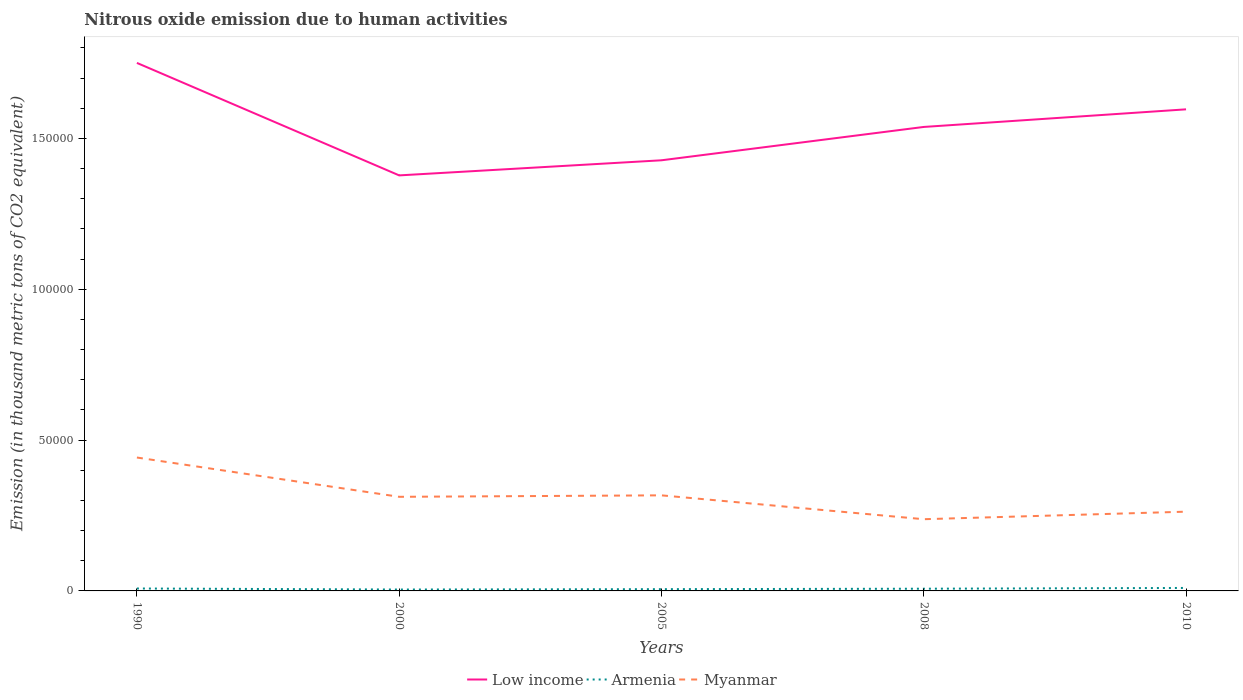How many different coloured lines are there?
Offer a very short reply. 3. Does the line corresponding to Armenia intersect with the line corresponding to Myanmar?
Offer a very short reply. No. Across all years, what is the maximum amount of nitrous oxide emitted in Myanmar?
Ensure brevity in your answer.  2.38e+04. In which year was the amount of nitrous oxide emitted in Myanmar maximum?
Keep it short and to the point. 2008. What is the total amount of nitrous oxide emitted in Myanmar in the graph?
Provide a short and direct response. -2497.4. What is the difference between the highest and the second highest amount of nitrous oxide emitted in Myanmar?
Give a very brief answer. 2.04e+04. How many years are there in the graph?
Keep it short and to the point. 5. Does the graph contain grids?
Give a very brief answer. No. How many legend labels are there?
Your response must be concise. 3. How are the legend labels stacked?
Provide a short and direct response. Horizontal. What is the title of the graph?
Keep it short and to the point. Nitrous oxide emission due to human activities. What is the label or title of the X-axis?
Ensure brevity in your answer.  Years. What is the label or title of the Y-axis?
Make the answer very short. Emission (in thousand metric tons of CO2 equivalent). What is the Emission (in thousand metric tons of CO2 equivalent) in Low income in 1990?
Offer a very short reply. 1.75e+05. What is the Emission (in thousand metric tons of CO2 equivalent) in Armenia in 1990?
Ensure brevity in your answer.  805. What is the Emission (in thousand metric tons of CO2 equivalent) of Myanmar in 1990?
Make the answer very short. 4.42e+04. What is the Emission (in thousand metric tons of CO2 equivalent) of Low income in 2000?
Your answer should be compact. 1.38e+05. What is the Emission (in thousand metric tons of CO2 equivalent) of Armenia in 2000?
Your answer should be compact. 461.6. What is the Emission (in thousand metric tons of CO2 equivalent) in Myanmar in 2000?
Provide a short and direct response. 3.12e+04. What is the Emission (in thousand metric tons of CO2 equivalent) of Low income in 2005?
Your answer should be compact. 1.43e+05. What is the Emission (in thousand metric tons of CO2 equivalent) of Armenia in 2005?
Give a very brief answer. 583.5. What is the Emission (in thousand metric tons of CO2 equivalent) of Myanmar in 2005?
Ensure brevity in your answer.  3.17e+04. What is the Emission (in thousand metric tons of CO2 equivalent) in Low income in 2008?
Keep it short and to the point. 1.54e+05. What is the Emission (in thousand metric tons of CO2 equivalent) in Armenia in 2008?
Ensure brevity in your answer.  731.4. What is the Emission (in thousand metric tons of CO2 equivalent) of Myanmar in 2008?
Give a very brief answer. 2.38e+04. What is the Emission (in thousand metric tons of CO2 equivalent) in Low income in 2010?
Provide a short and direct response. 1.60e+05. What is the Emission (in thousand metric tons of CO2 equivalent) of Armenia in 2010?
Offer a very short reply. 985.9. What is the Emission (in thousand metric tons of CO2 equivalent) in Myanmar in 2010?
Provide a succinct answer. 2.63e+04. Across all years, what is the maximum Emission (in thousand metric tons of CO2 equivalent) of Low income?
Make the answer very short. 1.75e+05. Across all years, what is the maximum Emission (in thousand metric tons of CO2 equivalent) of Armenia?
Your answer should be compact. 985.9. Across all years, what is the maximum Emission (in thousand metric tons of CO2 equivalent) of Myanmar?
Your response must be concise. 4.42e+04. Across all years, what is the minimum Emission (in thousand metric tons of CO2 equivalent) in Low income?
Your response must be concise. 1.38e+05. Across all years, what is the minimum Emission (in thousand metric tons of CO2 equivalent) in Armenia?
Keep it short and to the point. 461.6. Across all years, what is the minimum Emission (in thousand metric tons of CO2 equivalent) in Myanmar?
Your answer should be compact. 2.38e+04. What is the total Emission (in thousand metric tons of CO2 equivalent) in Low income in the graph?
Your answer should be very brief. 7.69e+05. What is the total Emission (in thousand metric tons of CO2 equivalent) in Armenia in the graph?
Your response must be concise. 3567.4. What is the total Emission (in thousand metric tons of CO2 equivalent) of Myanmar in the graph?
Ensure brevity in your answer.  1.57e+05. What is the difference between the Emission (in thousand metric tons of CO2 equivalent) in Low income in 1990 and that in 2000?
Your answer should be very brief. 3.73e+04. What is the difference between the Emission (in thousand metric tons of CO2 equivalent) of Armenia in 1990 and that in 2000?
Give a very brief answer. 343.4. What is the difference between the Emission (in thousand metric tons of CO2 equivalent) of Myanmar in 1990 and that in 2000?
Give a very brief answer. 1.30e+04. What is the difference between the Emission (in thousand metric tons of CO2 equivalent) in Low income in 1990 and that in 2005?
Your answer should be very brief. 3.23e+04. What is the difference between the Emission (in thousand metric tons of CO2 equivalent) of Armenia in 1990 and that in 2005?
Provide a short and direct response. 221.5. What is the difference between the Emission (in thousand metric tons of CO2 equivalent) of Myanmar in 1990 and that in 2005?
Offer a very short reply. 1.25e+04. What is the difference between the Emission (in thousand metric tons of CO2 equivalent) of Low income in 1990 and that in 2008?
Ensure brevity in your answer.  2.12e+04. What is the difference between the Emission (in thousand metric tons of CO2 equivalent) in Armenia in 1990 and that in 2008?
Your response must be concise. 73.6. What is the difference between the Emission (in thousand metric tons of CO2 equivalent) in Myanmar in 1990 and that in 2008?
Your answer should be compact. 2.04e+04. What is the difference between the Emission (in thousand metric tons of CO2 equivalent) in Low income in 1990 and that in 2010?
Provide a short and direct response. 1.54e+04. What is the difference between the Emission (in thousand metric tons of CO2 equivalent) in Armenia in 1990 and that in 2010?
Offer a very short reply. -180.9. What is the difference between the Emission (in thousand metric tons of CO2 equivalent) of Myanmar in 1990 and that in 2010?
Your answer should be very brief. 1.80e+04. What is the difference between the Emission (in thousand metric tons of CO2 equivalent) of Low income in 2000 and that in 2005?
Offer a terse response. -5007.3. What is the difference between the Emission (in thousand metric tons of CO2 equivalent) of Armenia in 2000 and that in 2005?
Ensure brevity in your answer.  -121.9. What is the difference between the Emission (in thousand metric tons of CO2 equivalent) of Myanmar in 2000 and that in 2005?
Give a very brief answer. -485.9. What is the difference between the Emission (in thousand metric tons of CO2 equivalent) of Low income in 2000 and that in 2008?
Make the answer very short. -1.61e+04. What is the difference between the Emission (in thousand metric tons of CO2 equivalent) in Armenia in 2000 and that in 2008?
Offer a very short reply. -269.8. What is the difference between the Emission (in thousand metric tons of CO2 equivalent) in Myanmar in 2000 and that in 2008?
Provide a succinct answer. 7425.1. What is the difference between the Emission (in thousand metric tons of CO2 equivalent) in Low income in 2000 and that in 2010?
Your answer should be compact. -2.19e+04. What is the difference between the Emission (in thousand metric tons of CO2 equivalent) of Armenia in 2000 and that in 2010?
Make the answer very short. -524.3. What is the difference between the Emission (in thousand metric tons of CO2 equivalent) of Myanmar in 2000 and that in 2010?
Give a very brief answer. 4927.7. What is the difference between the Emission (in thousand metric tons of CO2 equivalent) of Low income in 2005 and that in 2008?
Ensure brevity in your answer.  -1.11e+04. What is the difference between the Emission (in thousand metric tons of CO2 equivalent) of Armenia in 2005 and that in 2008?
Give a very brief answer. -147.9. What is the difference between the Emission (in thousand metric tons of CO2 equivalent) of Myanmar in 2005 and that in 2008?
Provide a succinct answer. 7911. What is the difference between the Emission (in thousand metric tons of CO2 equivalent) in Low income in 2005 and that in 2010?
Your response must be concise. -1.69e+04. What is the difference between the Emission (in thousand metric tons of CO2 equivalent) in Armenia in 2005 and that in 2010?
Give a very brief answer. -402.4. What is the difference between the Emission (in thousand metric tons of CO2 equivalent) of Myanmar in 2005 and that in 2010?
Offer a terse response. 5413.6. What is the difference between the Emission (in thousand metric tons of CO2 equivalent) in Low income in 2008 and that in 2010?
Make the answer very short. -5836.5. What is the difference between the Emission (in thousand metric tons of CO2 equivalent) of Armenia in 2008 and that in 2010?
Make the answer very short. -254.5. What is the difference between the Emission (in thousand metric tons of CO2 equivalent) in Myanmar in 2008 and that in 2010?
Your answer should be compact. -2497.4. What is the difference between the Emission (in thousand metric tons of CO2 equivalent) in Low income in 1990 and the Emission (in thousand metric tons of CO2 equivalent) in Armenia in 2000?
Keep it short and to the point. 1.75e+05. What is the difference between the Emission (in thousand metric tons of CO2 equivalent) in Low income in 1990 and the Emission (in thousand metric tons of CO2 equivalent) in Myanmar in 2000?
Keep it short and to the point. 1.44e+05. What is the difference between the Emission (in thousand metric tons of CO2 equivalent) in Armenia in 1990 and the Emission (in thousand metric tons of CO2 equivalent) in Myanmar in 2000?
Provide a short and direct response. -3.04e+04. What is the difference between the Emission (in thousand metric tons of CO2 equivalent) of Low income in 1990 and the Emission (in thousand metric tons of CO2 equivalent) of Armenia in 2005?
Keep it short and to the point. 1.74e+05. What is the difference between the Emission (in thousand metric tons of CO2 equivalent) in Low income in 1990 and the Emission (in thousand metric tons of CO2 equivalent) in Myanmar in 2005?
Provide a short and direct response. 1.43e+05. What is the difference between the Emission (in thousand metric tons of CO2 equivalent) in Armenia in 1990 and the Emission (in thousand metric tons of CO2 equivalent) in Myanmar in 2005?
Keep it short and to the point. -3.09e+04. What is the difference between the Emission (in thousand metric tons of CO2 equivalent) in Low income in 1990 and the Emission (in thousand metric tons of CO2 equivalent) in Armenia in 2008?
Your answer should be very brief. 1.74e+05. What is the difference between the Emission (in thousand metric tons of CO2 equivalent) of Low income in 1990 and the Emission (in thousand metric tons of CO2 equivalent) of Myanmar in 2008?
Provide a short and direct response. 1.51e+05. What is the difference between the Emission (in thousand metric tons of CO2 equivalent) in Armenia in 1990 and the Emission (in thousand metric tons of CO2 equivalent) in Myanmar in 2008?
Make the answer very short. -2.30e+04. What is the difference between the Emission (in thousand metric tons of CO2 equivalent) in Low income in 1990 and the Emission (in thousand metric tons of CO2 equivalent) in Armenia in 2010?
Make the answer very short. 1.74e+05. What is the difference between the Emission (in thousand metric tons of CO2 equivalent) of Low income in 1990 and the Emission (in thousand metric tons of CO2 equivalent) of Myanmar in 2010?
Offer a terse response. 1.49e+05. What is the difference between the Emission (in thousand metric tons of CO2 equivalent) of Armenia in 1990 and the Emission (in thousand metric tons of CO2 equivalent) of Myanmar in 2010?
Provide a succinct answer. -2.55e+04. What is the difference between the Emission (in thousand metric tons of CO2 equivalent) of Low income in 2000 and the Emission (in thousand metric tons of CO2 equivalent) of Armenia in 2005?
Make the answer very short. 1.37e+05. What is the difference between the Emission (in thousand metric tons of CO2 equivalent) of Low income in 2000 and the Emission (in thousand metric tons of CO2 equivalent) of Myanmar in 2005?
Give a very brief answer. 1.06e+05. What is the difference between the Emission (in thousand metric tons of CO2 equivalent) of Armenia in 2000 and the Emission (in thousand metric tons of CO2 equivalent) of Myanmar in 2005?
Provide a succinct answer. -3.12e+04. What is the difference between the Emission (in thousand metric tons of CO2 equivalent) in Low income in 2000 and the Emission (in thousand metric tons of CO2 equivalent) in Armenia in 2008?
Offer a very short reply. 1.37e+05. What is the difference between the Emission (in thousand metric tons of CO2 equivalent) of Low income in 2000 and the Emission (in thousand metric tons of CO2 equivalent) of Myanmar in 2008?
Make the answer very short. 1.14e+05. What is the difference between the Emission (in thousand metric tons of CO2 equivalent) in Armenia in 2000 and the Emission (in thousand metric tons of CO2 equivalent) in Myanmar in 2008?
Your response must be concise. -2.33e+04. What is the difference between the Emission (in thousand metric tons of CO2 equivalent) of Low income in 2000 and the Emission (in thousand metric tons of CO2 equivalent) of Armenia in 2010?
Make the answer very short. 1.37e+05. What is the difference between the Emission (in thousand metric tons of CO2 equivalent) of Low income in 2000 and the Emission (in thousand metric tons of CO2 equivalent) of Myanmar in 2010?
Give a very brief answer. 1.11e+05. What is the difference between the Emission (in thousand metric tons of CO2 equivalent) of Armenia in 2000 and the Emission (in thousand metric tons of CO2 equivalent) of Myanmar in 2010?
Ensure brevity in your answer.  -2.58e+04. What is the difference between the Emission (in thousand metric tons of CO2 equivalent) in Low income in 2005 and the Emission (in thousand metric tons of CO2 equivalent) in Armenia in 2008?
Make the answer very short. 1.42e+05. What is the difference between the Emission (in thousand metric tons of CO2 equivalent) in Low income in 2005 and the Emission (in thousand metric tons of CO2 equivalent) in Myanmar in 2008?
Provide a short and direct response. 1.19e+05. What is the difference between the Emission (in thousand metric tons of CO2 equivalent) in Armenia in 2005 and the Emission (in thousand metric tons of CO2 equivalent) in Myanmar in 2008?
Your answer should be very brief. -2.32e+04. What is the difference between the Emission (in thousand metric tons of CO2 equivalent) of Low income in 2005 and the Emission (in thousand metric tons of CO2 equivalent) of Armenia in 2010?
Keep it short and to the point. 1.42e+05. What is the difference between the Emission (in thousand metric tons of CO2 equivalent) of Low income in 2005 and the Emission (in thousand metric tons of CO2 equivalent) of Myanmar in 2010?
Offer a very short reply. 1.16e+05. What is the difference between the Emission (in thousand metric tons of CO2 equivalent) in Armenia in 2005 and the Emission (in thousand metric tons of CO2 equivalent) in Myanmar in 2010?
Make the answer very short. -2.57e+04. What is the difference between the Emission (in thousand metric tons of CO2 equivalent) in Low income in 2008 and the Emission (in thousand metric tons of CO2 equivalent) in Armenia in 2010?
Provide a short and direct response. 1.53e+05. What is the difference between the Emission (in thousand metric tons of CO2 equivalent) in Low income in 2008 and the Emission (in thousand metric tons of CO2 equivalent) in Myanmar in 2010?
Offer a terse response. 1.28e+05. What is the difference between the Emission (in thousand metric tons of CO2 equivalent) in Armenia in 2008 and the Emission (in thousand metric tons of CO2 equivalent) in Myanmar in 2010?
Offer a very short reply. -2.55e+04. What is the average Emission (in thousand metric tons of CO2 equivalent) in Low income per year?
Provide a succinct answer. 1.54e+05. What is the average Emission (in thousand metric tons of CO2 equivalent) of Armenia per year?
Keep it short and to the point. 713.48. What is the average Emission (in thousand metric tons of CO2 equivalent) of Myanmar per year?
Your answer should be very brief. 3.14e+04. In the year 1990, what is the difference between the Emission (in thousand metric tons of CO2 equivalent) in Low income and Emission (in thousand metric tons of CO2 equivalent) in Armenia?
Your response must be concise. 1.74e+05. In the year 1990, what is the difference between the Emission (in thousand metric tons of CO2 equivalent) in Low income and Emission (in thousand metric tons of CO2 equivalent) in Myanmar?
Ensure brevity in your answer.  1.31e+05. In the year 1990, what is the difference between the Emission (in thousand metric tons of CO2 equivalent) of Armenia and Emission (in thousand metric tons of CO2 equivalent) of Myanmar?
Offer a terse response. -4.34e+04. In the year 2000, what is the difference between the Emission (in thousand metric tons of CO2 equivalent) of Low income and Emission (in thousand metric tons of CO2 equivalent) of Armenia?
Offer a terse response. 1.37e+05. In the year 2000, what is the difference between the Emission (in thousand metric tons of CO2 equivalent) of Low income and Emission (in thousand metric tons of CO2 equivalent) of Myanmar?
Keep it short and to the point. 1.07e+05. In the year 2000, what is the difference between the Emission (in thousand metric tons of CO2 equivalent) in Armenia and Emission (in thousand metric tons of CO2 equivalent) in Myanmar?
Provide a short and direct response. -3.07e+04. In the year 2005, what is the difference between the Emission (in thousand metric tons of CO2 equivalent) of Low income and Emission (in thousand metric tons of CO2 equivalent) of Armenia?
Your response must be concise. 1.42e+05. In the year 2005, what is the difference between the Emission (in thousand metric tons of CO2 equivalent) of Low income and Emission (in thousand metric tons of CO2 equivalent) of Myanmar?
Provide a succinct answer. 1.11e+05. In the year 2005, what is the difference between the Emission (in thousand metric tons of CO2 equivalent) in Armenia and Emission (in thousand metric tons of CO2 equivalent) in Myanmar?
Your answer should be very brief. -3.11e+04. In the year 2008, what is the difference between the Emission (in thousand metric tons of CO2 equivalent) of Low income and Emission (in thousand metric tons of CO2 equivalent) of Armenia?
Ensure brevity in your answer.  1.53e+05. In the year 2008, what is the difference between the Emission (in thousand metric tons of CO2 equivalent) in Low income and Emission (in thousand metric tons of CO2 equivalent) in Myanmar?
Provide a short and direct response. 1.30e+05. In the year 2008, what is the difference between the Emission (in thousand metric tons of CO2 equivalent) in Armenia and Emission (in thousand metric tons of CO2 equivalent) in Myanmar?
Ensure brevity in your answer.  -2.30e+04. In the year 2010, what is the difference between the Emission (in thousand metric tons of CO2 equivalent) of Low income and Emission (in thousand metric tons of CO2 equivalent) of Armenia?
Ensure brevity in your answer.  1.59e+05. In the year 2010, what is the difference between the Emission (in thousand metric tons of CO2 equivalent) in Low income and Emission (in thousand metric tons of CO2 equivalent) in Myanmar?
Make the answer very short. 1.33e+05. In the year 2010, what is the difference between the Emission (in thousand metric tons of CO2 equivalent) of Armenia and Emission (in thousand metric tons of CO2 equivalent) of Myanmar?
Keep it short and to the point. -2.53e+04. What is the ratio of the Emission (in thousand metric tons of CO2 equivalent) in Low income in 1990 to that in 2000?
Offer a very short reply. 1.27. What is the ratio of the Emission (in thousand metric tons of CO2 equivalent) of Armenia in 1990 to that in 2000?
Make the answer very short. 1.74. What is the ratio of the Emission (in thousand metric tons of CO2 equivalent) in Myanmar in 1990 to that in 2000?
Ensure brevity in your answer.  1.42. What is the ratio of the Emission (in thousand metric tons of CO2 equivalent) of Low income in 1990 to that in 2005?
Give a very brief answer. 1.23. What is the ratio of the Emission (in thousand metric tons of CO2 equivalent) in Armenia in 1990 to that in 2005?
Your answer should be very brief. 1.38. What is the ratio of the Emission (in thousand metric tons of CO2 equivalent) of Myanmar in 1990 to that in 2005?
Your answer should be compact. 1.4. What is the ratio of the Emission (in thousand metric tons of CO2 equivalent) in Low income in 1990 to that in 2008?
Give a very brief answer. 1.14. What is the ratio of the Emission (in thousand metric tons of CO2 equivalent) of Armenia in 1990 to that in 2008?
Make the answer very short. 1.1. What is the ratio of the Emission (in thousand metric tons of CO2 equivalent) of Myanmar in 1990 to that in 2008?
Your answer should be very brief. 1.86. What is the ratio of the Emission (in thousand metric tons of CO2 equivalent) in Low income in 1990 to that in 2010?
Make the answer very short. 1.1. What is the ratio of the Emission (in thousand metric tons of CO2 equivalent) of Armenia in 1990 to that in 2010?
Provide a succinct answer. 0.82. What is the ratio of the Emission (in thousand metric tons of CO2 equivalent) of Myanmar in 1990 to that in 2010?
Your answer should be very brief. 1.68. What is the ratio of the Emission (in thousand metric tons of CO2 equivalent) in Low income in 2000 to that in 2005?
Make the answer very short. 0.96. What is the ratio of the Emission (in thousand metric tons of CO2 equivalent) in Armenia in 2000 to that in 2005?
Your response must be concise. 0.79. What is the ratio of the Emission (in thousand metric tons of CO2 equivalent) of Myanmar in 2000 to that in 2005?
Ensure brevity in your answer.  0.98. What is the ratio of the Emission (in thousand metric tons of CO2 equivalent) in Low income in 2000 to that in 2008?
Your response must be concise. 0.9. What is the ratio of the Emission (in thousand metric tons of CO2 equivalent) of Armenia in 2000 to that in 2008?
Provide a short and direct response. 0.63. What is the ratio of the Emission (in thousand metric tons of CO2 equivalent) in Myanmar in 2000 to that in 2008?
Offer a terse response. 1.31. What is the ratio of the Emission (in thousand metric tons of CO2 equivalent) of Low income in 2000 to that in 2010?
Make the answer very short. 0.86. What is the ratio of the Emission (in thousand metric tons of CO2 equivalent) of Armenia in 2000 to that in 2010?
Provide a succinct answer. 0.47. What is the ratio of the Emission (in thousand metric tons of CO2 equivalent) of Myanmar in 2000 to that in 2010?
Your answer should be very brief. 1.19. What is the ratio of the Emission (in thousand metric tons of CO2 equivalent) in Low income in 2005 to that in 2008?
Offer a very short reply. 0.93. What is the ratio of the Emission (in thousand metric tons of CO2 equivalent) in Armenia in 2005 to that in 2008?
Provide a short and direct response. 0.8. What is the ratio of the Emission (in thousand metric tons of CO2 equivalent) of Myanmar in 2005 to that in 2008?
Offer a terse response. 1.33. What is the ratio of the Emission (in thousand metric tons of CO2 equivalent) in Low income in 2005 to that in 2010?
Keep it short and to the point. 0.89. What is the ratio of the Emission (in thousand metric tons of CO2 equivalent) of Armenia in 2005 to that in 2010?
Make the answer very short. 0.59. What is the ratio of the Emission (in thousand metric tons of CO2 equivalent) of Myanmar in 2005 to that in 2010?
Offer a very short reply. 1.21. What is the ratio of the Emission (in thousand metric tons of CO2 equivalent) of Low income in 2008 to that in 2010?
Make the answer very short. 0.96. What is the ratio of the Emission (in thousand metric tons of CO2 equivalent) in Armenia in 2008 to that in 2010?
Offer a very short reply. 0.74. What is the ratio of the Emission (in thousand metric tons of CO2 equivalent) in Myanmar in 2008 to that in 2010?
Ensure brevity in your answer.  0.9. What is the difference between the highest and the second highest Emission (in thousand metric tons of CO2 equivalent) in Low income?
Offer a terse response. 1.54e+04. What is the difference between the highest and the second highest Emission (in thousand metric tons of CO2 equivalent) in Armenia?
Your answer should be compact. 180.9. What is the difference between the highest and the second highest Emission (in thousand metric tons of CO2 equivalent) in Myanmar?
Your response must be concise. 1.25e+04. What is the difference between the highest and the lowest Emission (in thousand metric tons of CO2 equivalent) of Low income?
Provide a succinct answer. 3.73e+04. What is the difference between the highest and the lowest Emission (in thousand metric tons of CO2 equivalent) in Armenia?
Your response must be concise. 524.3. What is the difference between the highest and the lowest Emission (in thousand metric tons of CO2 equivalent) in Myanmar?
Your answer should be very brief. 2.04e+04. 